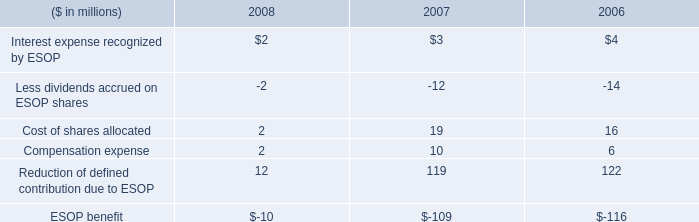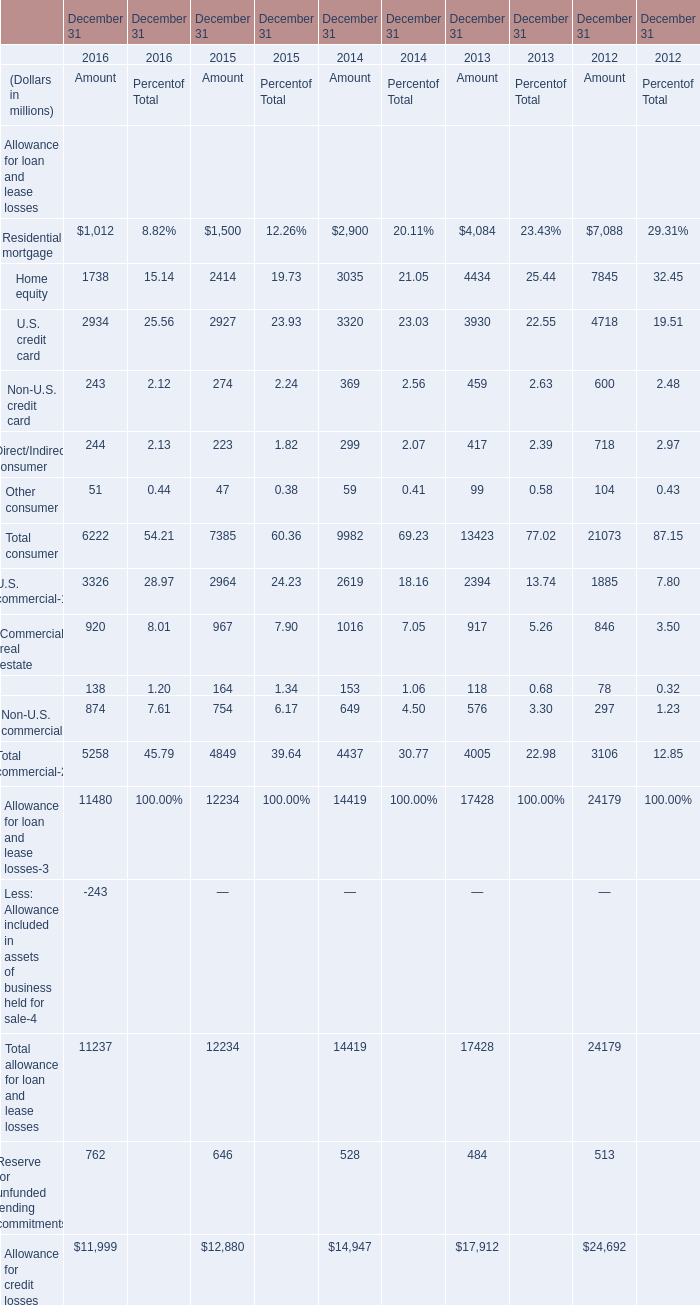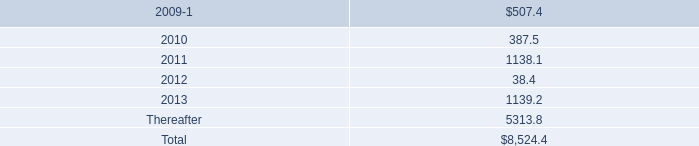Which year is Residential mortgage for amount the highest? 
Answer: 2012. 